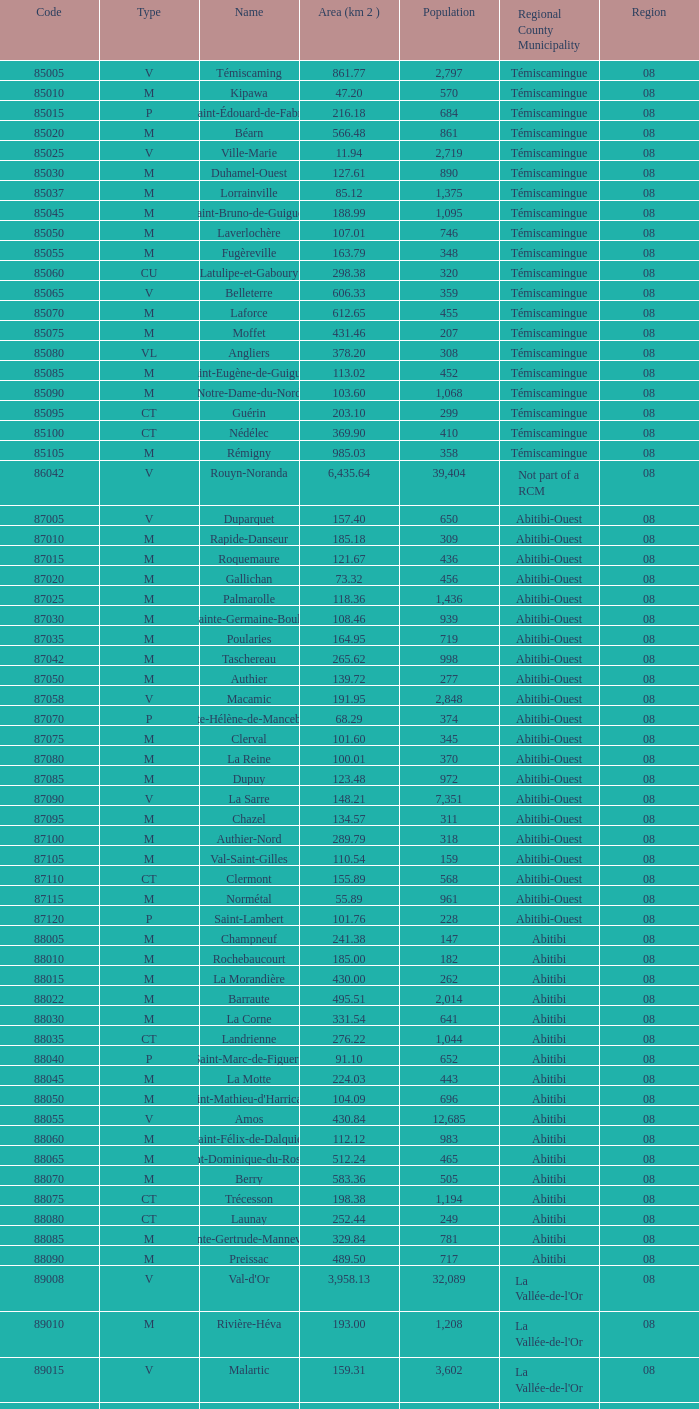What was the region for Malartic with 159.31 km2? 0.0. Give me the full table as a dictionary. {'header': ['Code', 'Type', 'Name', 'Area (km 2 )', 'Population', 'Regional County Municipality', 'Region'], 'rows': [['85005', 'V', 'Témiscaming', '861.77', '2,797', 'Témiscamingue', '08'], ['85010', 'M', 'Kipawa', '47.20', '570', 'Témiscamingue', '08'], ['85015', 'P', 'Saint-Édouard-de-Fabre', '216.18', '684', 'Témiscamingue', '08'], ['85020', 'M', 'Béarn', '566.48', '861', 'Témiscamingue', '08'], ['85025', 'V', 'Ville-Marie', '11.94', '2,719', 'Témiscamingue', '08'], ['85030', 'M', 'Duhamel-Ouest', '127.61', '890', 'Témiscamingue', '08'], ['85037', 'M', 'Lorrainville', '85.12', '1,375', 'Témiscamingue', '08'], ['85045', 'M', 'Saint-Bruno-de-Guigues', '188.99', '1,095', 'Témiscamingue', '08'], ['85050', 'M', 'Laverlochère', '107.01', '746', 'Témiscamingue', '08'], ['85055', 'M', 'Fugèreville', '163.79', '348', 'Témiscamingue', '08'], ['85060', 'CU', 'Latulipe-et-Gaboury', '298.38', '320', 'Témiscamingue', '08'], ['85065', 'V', 'Belleterre', '606.33', '359', 'Témiscamingue', '08'], ['85070', 'M', 'Laforce', '612.65', '455', 'Témiscamingue', '08'], ['85075', 'M', 'Moffet', '431.46', '207', 'Témiscamingue', '08'], ['85080', 'VL', 'Angliers', '378.20', '308', 'Témiscamingue', '08'], ['85085', 'M', 'Saint-Eugène-de-Guigues', '113.02', '452', 'Témiscamingue', '08'], ['85090', 'M', 'Notre-Dame-du-Nord', '103.60', '1,068', 'Témiscamingue', '08'], ['85095', 'CT', 'Guérin', '203.10', '299', 'Témiscamingue', '08'], ['85100', 'CT', 'Nédélec', '369.90', '410', 'Témiscamingue', '08'], ['85105', 'M', 'Rémigny', '985.03', '358', 'Témiscamingue', '08'], ['86042', 'V', 'Rouyn-Noranda', '6,435.64', '39,404', 'Not part of a RCM', '08'], ['87005', 'V', 'Duparquet', '157.40', '650', 'Abitibi-Ouest', '08'], ['87010', 'M', 'Rapide-Danseur', '185.18', '309', 'Abitibi-Ouest', '08'], ['87015', 'M', 'Roquemaure', '121.67', '436', 'Abitibi-Ouest', '08'], ['87020', 'M', 'Gallichan', '73.32', '456', 'Abitibi-Ouest', '08'], ['87025', 'M', 'Palmarolle', '118.36', '1,436', 'Abitibi-Ouest', '08'], ['87030', 'M', 'Sainte-Germaine-Boulé', '108.46', '939', 'Abitibi-Ouest', '08'], ['87035', 'M', 'Poularies', '164.95', '719', 'Abitibi-Ouest', '08'], ['87042', 'M', 'Taschereau', '265.62', '998', 'Abitibi-Ouest', '08'], ['87050', 'M', 'Authier', '139.72', '277', 'Abitibi-Ouest', '08'], ['87058', 'V', 'Macamic', '191.95', '2,848', 'Abitibi-Ouest', '08'], ['87070', 'P', 'Sainte-Hélène-de-Mancebourg', '68.29', '374', 'Abitibi-Ouest', '08'], ['87075', 'M', 'Clerval', '101.60', '345', 'Abitibi-Ouest', '08'], ['87080', 'M', 'La Reine', '100.01', '370', 'Abitibi-Ouest', '08'], ['87085', 'M', 'Dupuy', '123.48', '972', 'Abitibi-Ouest', '08'], ['87090', 'V', 'La Sarre', '148.21', '7,351', 'Abitibi-Ouest', '08'], ['87095', 'M', 'Chazel', '134.57', '311', 'Abitibi-Ouest', '08'], ['87100', 'M', 'Authier-Nord', '289.79', '318', 'Abitibi-Ouest', '08'], ['87105', 'M', 'Val-Saint-Gilles', '110.54', '159', 'Abitibi-Ouest', '08'], ['87110', 'CT', 'Clermont', '155.89', '568', 'Abitibi-Ouest', '08'], ['87115', 'M', 'Normétal', '55.89', '961', 'Abitibi-Ouest', '08'], ['87120', 'P', 'Saint-Lambert', '101.76', '228', 'Abitibi-Ouest', '08'], ['88005', 'M', 'Champneuf', '241.38', '147', 'Abitibi', '08'], ['88010', 'M', 'Rochebaucourt', '185.00', '182', 'Abitibi', '08'], ['88015', 'M', 'La Morandière', '430.00', '262', 'Abitibi', '08'], ['88022', 'M', 'Barraute', '495.51', '2,014', 'Abitibi', '08'], ['88030', 'M', 'La Corne', '331.54', '641', 'Abitibi', '08'], ['88035', 'CT', 'Landrienne', '276.22', '1,044', 'Abitibi', '08'], ['88040', 'P', 'Saint-Marc-de-Figuery', '91.10', '652', 'Abitibi', '08'], ['88045', 'M', 'La Motte', '224.03', '443', 'Abitibi', '08'], ['88050', 'M', "Saint-Mathieu-d'Harricana", '104.09', '696', 'Abitibi', '08'], ['88055', 'V', 'Amos', '430.84', '12,685', 'Abitibi', '08'], ['88060', 'M', 'Saint-Félix-de-Dalquier', '112.12', '983', 'Abitibi', '08'], ['88065', 'M', 'Saint-Dominique-du-Rosaire', '512.24', '465', 'Abitibi', '08'], ['88070', 'M', 'Berry', '583.36', '505', 'Abitibi', '08'], ['88075', 'CT', 'Trécesson', '198.38', '1,194', 'Abitibi', '08'], ['88080', 'CT', 'Launay', '252.44', '249', 'Abitibi', '08'], ['88085', 'M', 'Sainte-Gertrude-Manneville', '329.84', '781', 'Abitibi', '08'], ['88090', 'M', 'Preissac', '489.50', '717', 'Abitibi', '08'], ['89008', 'V', "Val-d'Or", '3,958.13', '32,089', "La Vallée-de-l'Or", '08'], ['89010', 'M', 'Rivière-Héva', '193.00', '1,208', "La Vallée-de-l'Or", '08'], ['89015', 'V', 'Malartic', '159.31', '3,602', "La Vallée-de-l'Or", '08'], ['89040', 'V', 'Senneterre', '16,524.89', '3,165', "La Vallée-de-l'Or", '08'], ['89045', 'P', 'Senneterre', '432.98', '1,146', "La Vallée-de-l'Or", '08'], ['89050', 'M', 'Belcourt', '411.23', '261', "La Vallée-de-l'Or", '08']]} 